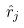<formula> <loc_0><loc_0><loc_500><loc_500>\hat { r } _ { j }</formula> 